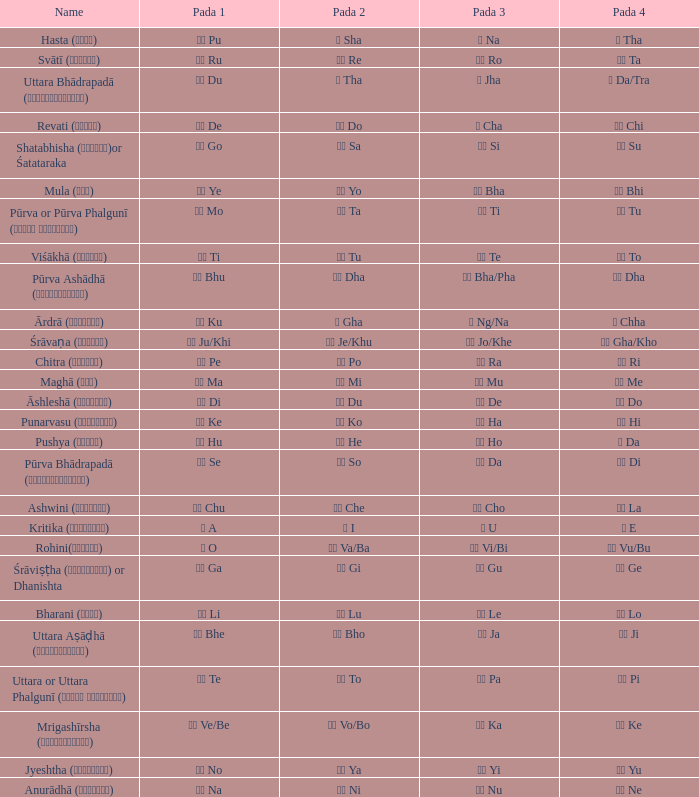Which Pada 3 has a Pada 1 of टे te? पा Pa. 